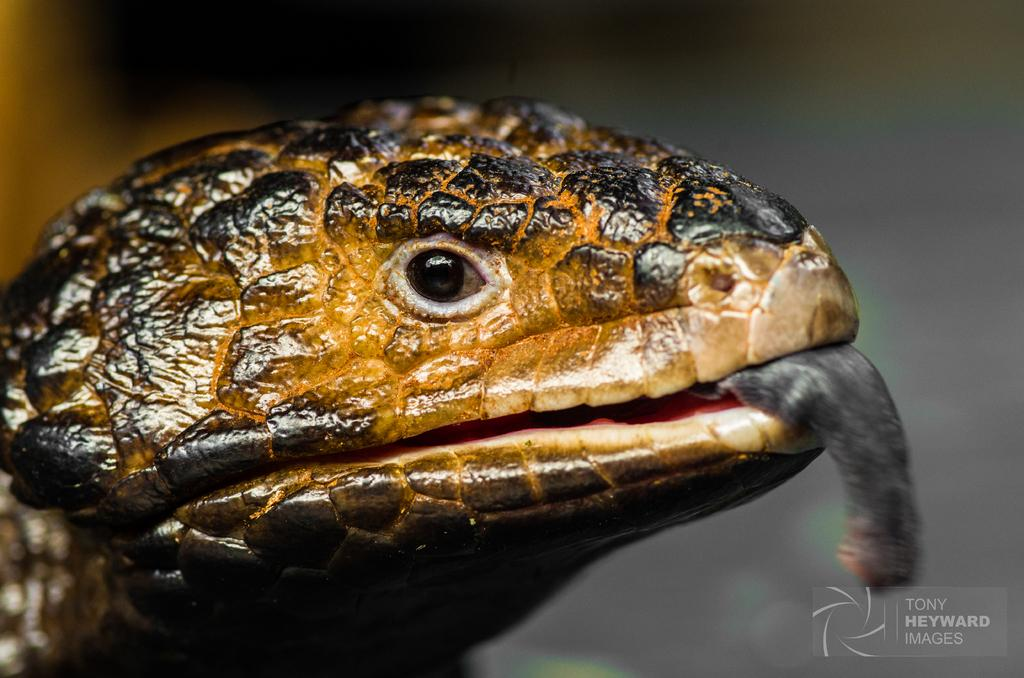What animal is present in the image? There is a snake in the picture. Can you describe the background of the image? The background of the image is blurry. Is there any text visible in the image? Yes, there is some text at the bottom right corner of the image. What type of soap is being used by the men in the image? There are no men or soap present in the image; it features a snake and a blurry background with text. 